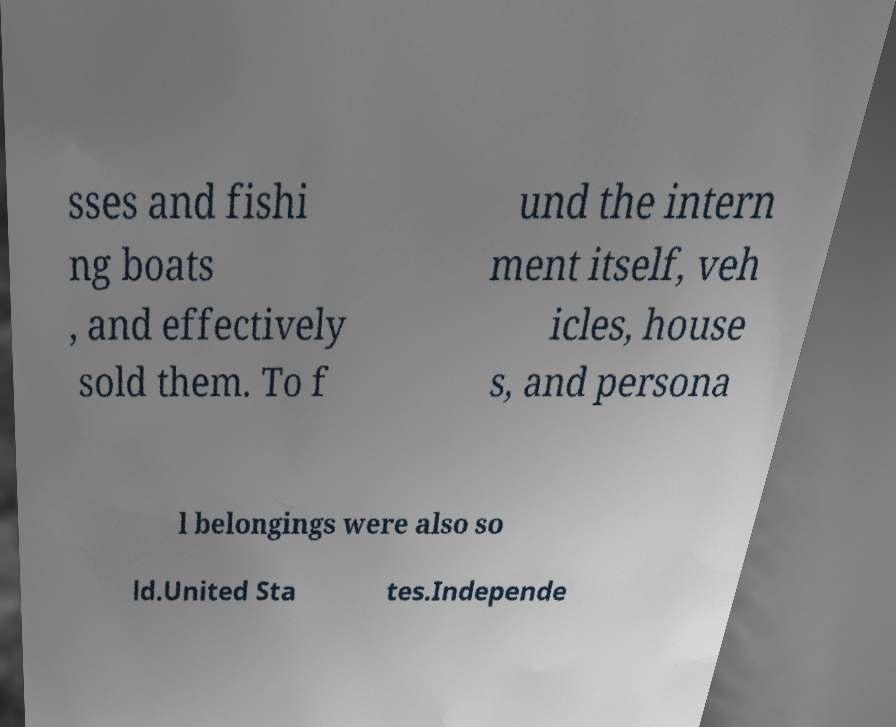There's text embedded in this image that I need extracted. Can you transcribe it verbatim? sses and fishi ng boats , and effectively sold them. To f und the intern ment itself, veh icles, house s, and persona l belongings were also so ld.United Sta tes.Independe 